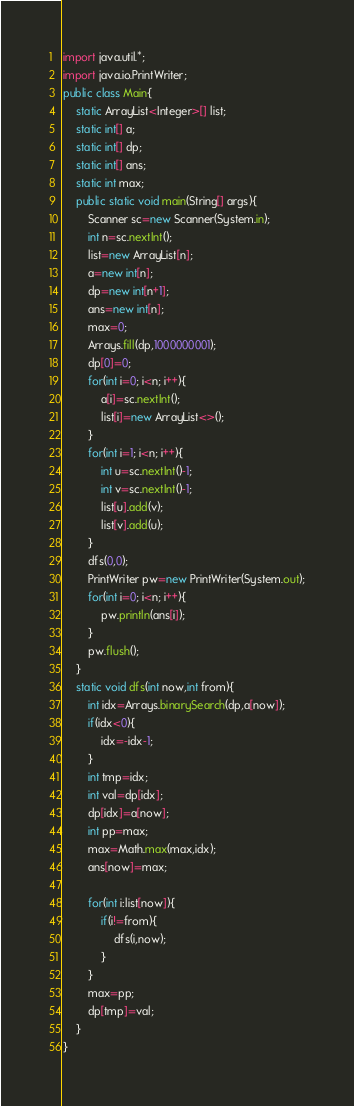<code> <loc_0><loc_0><loc_500><loc_500><_Java_>import java.util.*;
import java.io.PrintWriter;
public class Main{
	static ArrayList<Integer>[] list;
	static int[] a;
	static int[] dp;
	static int[] ans;
	static int max;
	public static void main(String[] args){
		Scanner sc=new Scanner(System.in);
		int n=sc.nextInt();
		list=new ArrayList[n];
		a=new int[n];
		dp=new int[n+1];
		ans=new int[n];
		max=0;
		Arrays.fill(dp,1000000001);
		dp[0]=0;
		for(int i=0; i<n; i++){
			a[i]=sc.nextInt();
			list[i]=new ArrayList<>();
		}
		for(int i=1; i<n; i++){
			int u=sc.nextInt()-1;
			int v=sc.nextInt()-1;
			list[u].add(v);
			list[v].add(u);
		}
		dfs(0,0);
		PrintWriter pw=new PrintWriter(System.out);
		for(int i=0; i<n; i++){
			pw.println(ans[i]);
		}
		pw.flush();
	}
	static void dfs(int now,int from){
		int idx=Arrays.binarySearch(dp,a[now]);
		if(idx<0){
			idx=-idx-1;
		}
		int tmp=idx;
		int val=dp[idx];
		dp[idx]=a[now];
		int pp=max;
		max=Math.max(max,idx);
		ans[now]=max;
		
		for(int i:list[now]){
			if(i!=from){
				dfs(i,now);
			}
		}
		max=pp;
		dp[tmp]=val;
	}
}</code> 